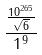Convert formula to latex. <formula><loc_0><loc_0><loc_500><loc_500>\frac { \frac { 1 0 ^ { 2 6 5 } } { \sqrt { 6 } } } { 1 ^ { 9 } }</formula> 